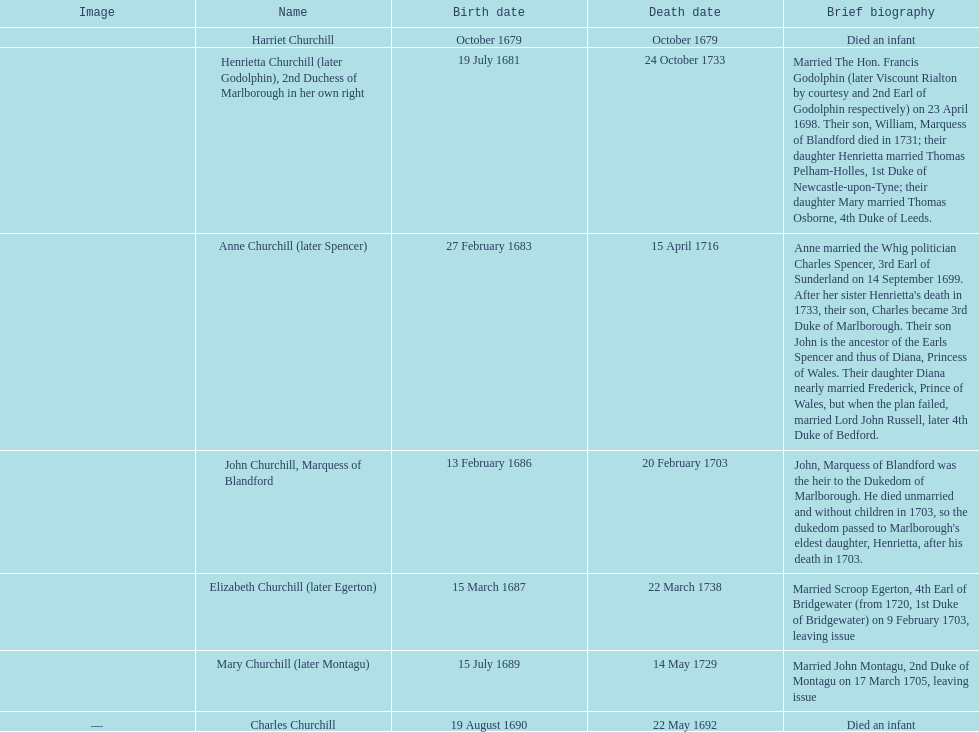What is the date of birth for sarah churchill's eldest child? October 1679. 